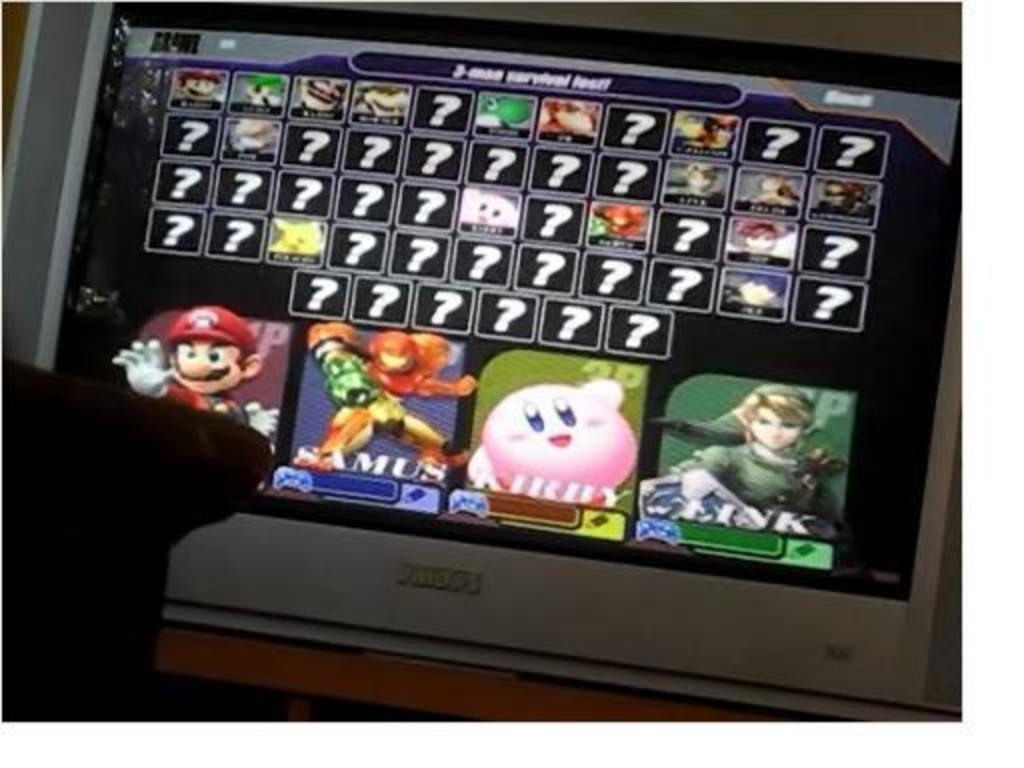What electronic device can be seen in the image? There is a television in the image. What is the television placed on? The television is on a wooden surface. What is being displayed on the television screen? Symbols and animated figures are visible on the television screen. Can you describe the object on the left side of the image? Unfortunately, the provided facts do not give enough information to describe the object on the left side of the image. How does the bear use its muscle to sort objects in the image? There is no bear or any sorting activity present in the image. 